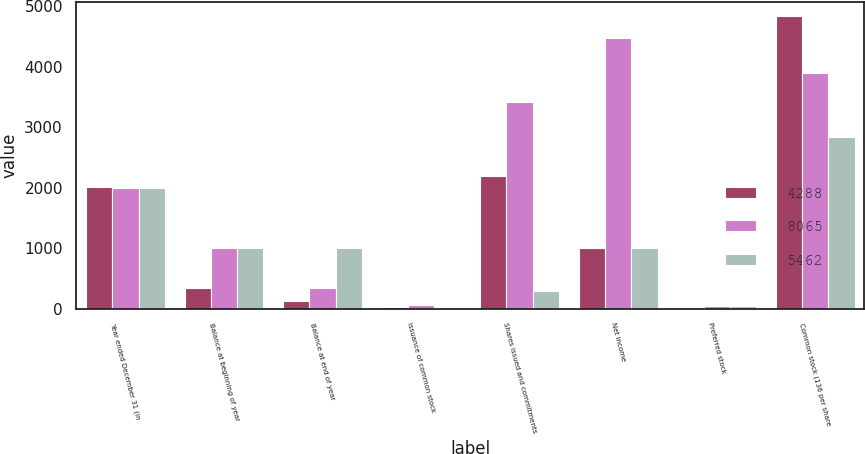<chart> <loc_0><loc_0><loc_500><loc_500><stacked_bar_chart><ecel><fcel>Year ended December 31 (in<fcel>Balance at beginning of year<fcel>Balance at end of year<fcel>Issuance of common stock<fcel>Shares issued and commitments<fcel>Net income<fcel>Preferred stock<fcel>Common stock (136 per share<nl><fcel>4288<fcel>2005<fcel>339<fcel>139<fcel>33<fcel>2193<fcel>1009<fcel>13<fcel>4831<nl><fcel>8065<fcel>2004<fcel>1009<fcel>339<fcel>72<fcel>3422<fcel>4466<fcel>52<fcel>3886<nl><fcel>5462<fcel>2003<fcel>1009<fcel>1009<fcel>20<fcel>290<fcel>1009<fcel>51<fcel>2838<nl></chart> 